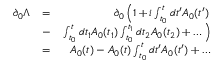<formula> <loc_0><loc_0><loc_500><loc_500>\begin{array} { r l r } { \partial _ { 0 } \Lambda } & { = } & { \partial _ { 0 } \left ( 1 + i \int _ { t _ { 0 } } ^ { t } d t ^ { \prime } A _ { 0 } ( t ^ { \prime } ) } \\ & { - } & { \int _ { t _ { 0 } } ^ { t } d t _ { 1 } A _ { 0 } ( t _ { 1 } ) \int _ { t _ { 0 } } ^ { t _ { 1 } } d t _ { 2 } A _ { 0 } ( t _ { 2 } ) + \dots \right ) } \\ & { = } & { A _ { 0 } ( t ) - A _ { 0 } ( t ) \int _ { t _ { 0 } } ^ { t } d t ^ { \prime } A _ { 0 } ( t ^ { \prime } ) + \dots } \end{array}</formula> 